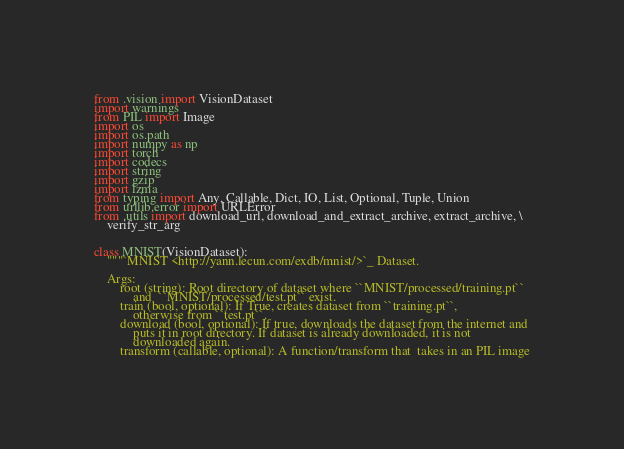Convert code to text. <code><loc_0><loc_0><loc_500><loc_500><_Python_>from .vision import VisionDataset
import warnings
from PIL import Image
import os
import os.path
import numpy as np
import torch
import codecs
import string
import gzip
import lzma
from typing import Any, Callable, Dict, IO, List, Optional, Tuple, Union
from urllib.error import URLError
from .utils import download_url, download_and_extract_archive, extract_archive, \
    verify_str_arg


class MNIST(VisionDataset):
    """`MNIST <http://yann.lecun.com/exdb/mnist/>`_ Dataset.

    Args:
        root (string): Root directory of dataset where ``MNIST/processed/training.pt``
            and  ``MNIST/processed/test.pt`` exist.
        train (bool, optional): If True, creates dataset from ``training.pt``,
            otherwise from ``test.pt``.
        download (bool, optional): If true, downloads the dataset from the internet and
            puts it in root directory. If dataset is already downloaded, it is not
            downloaded again.
        transform (callable, optional): A function/transform that  takes in an PIL image</code> 